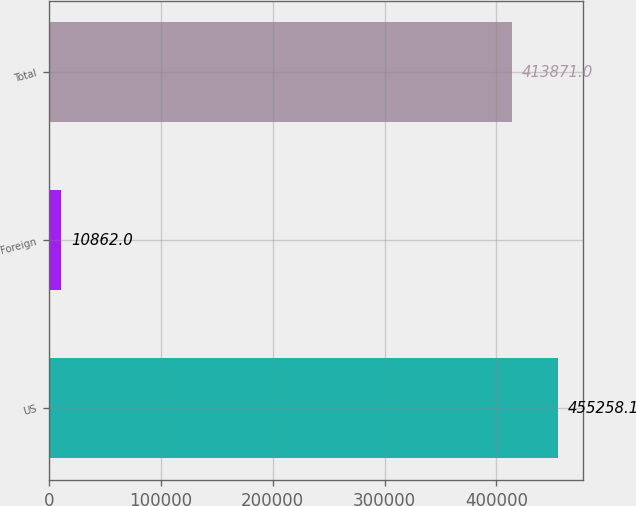<chart> <loc_0><loc_0><loc_500><loc_500><bar_chart><fcel>US<fcel>Foreign<fcel>Total<nl><fcel>455258<fcel>10862<fcel>413871<nl></chart> 